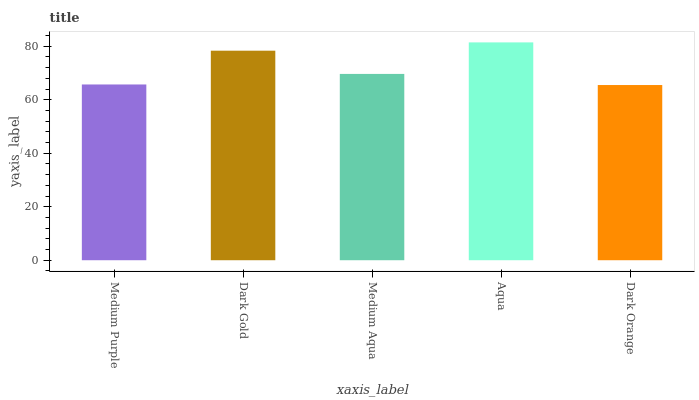Is Dark Orange the minimum?
Answer yes or no. Yes. Is Aqua the maximum?
Answer yes or no. Yes. Is Dark Gold the minimum?
Answer yes or no. No. Is Dark Gold the maximum?
Answer yes or no. No. Is Dark Gold greater than Medium Purple?
Answer yes or no. Yes. Is Medium Purple less than Dark Gold?
Answer yes or no. Yes. Is Medium Purple greater than Dark Gold?
Answer yes or no. No. Is Dark Gold less than Medium Purple?
Answer yes or no. No. Is Medium Aqua the high median?
Answer yes or no. Yes. Is Medium Aqua the low median?
Answer yes or no. Yes. Is Dark Gold the high median?
Answer yes or no. No. Is Medium Purple the low median?
Answer yes or no. No. 